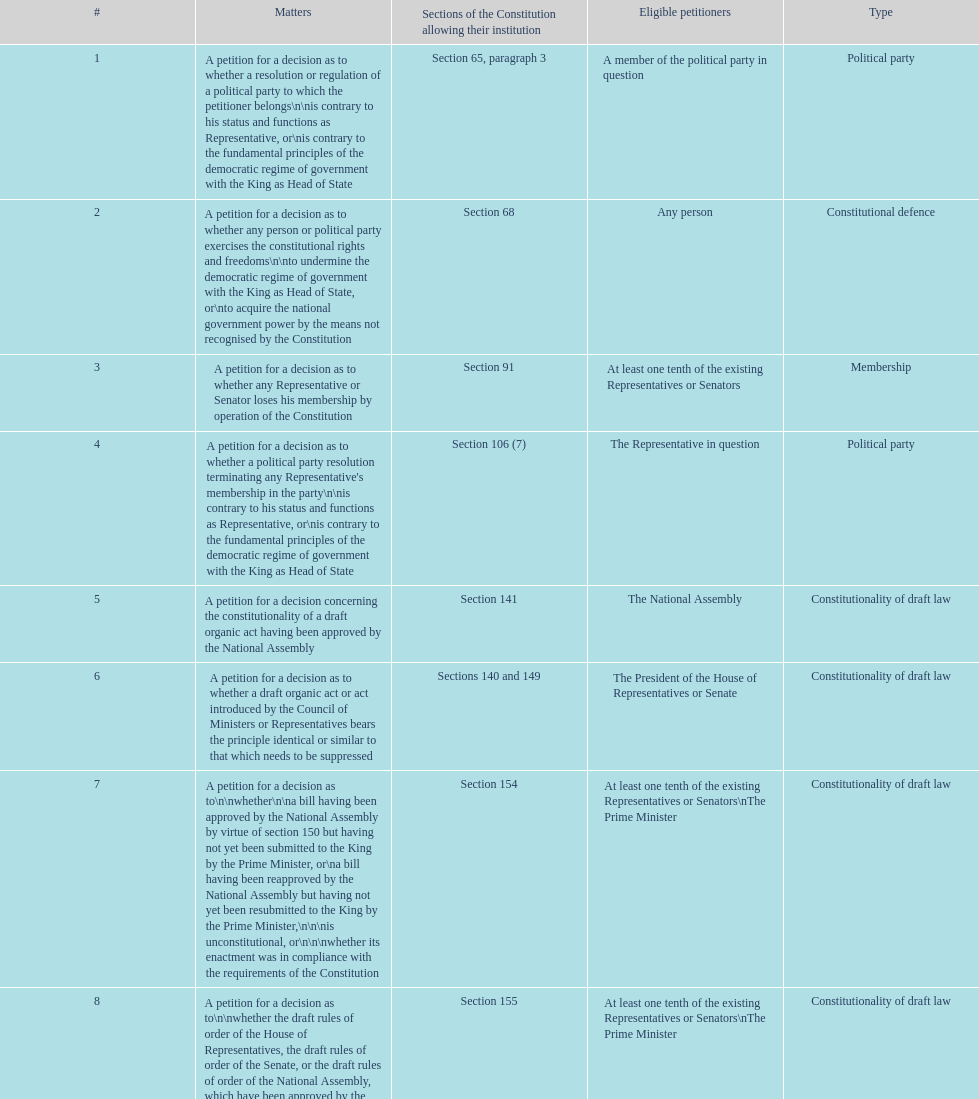True or false: any person has the ability to petition on topics 2 and 1 True. 